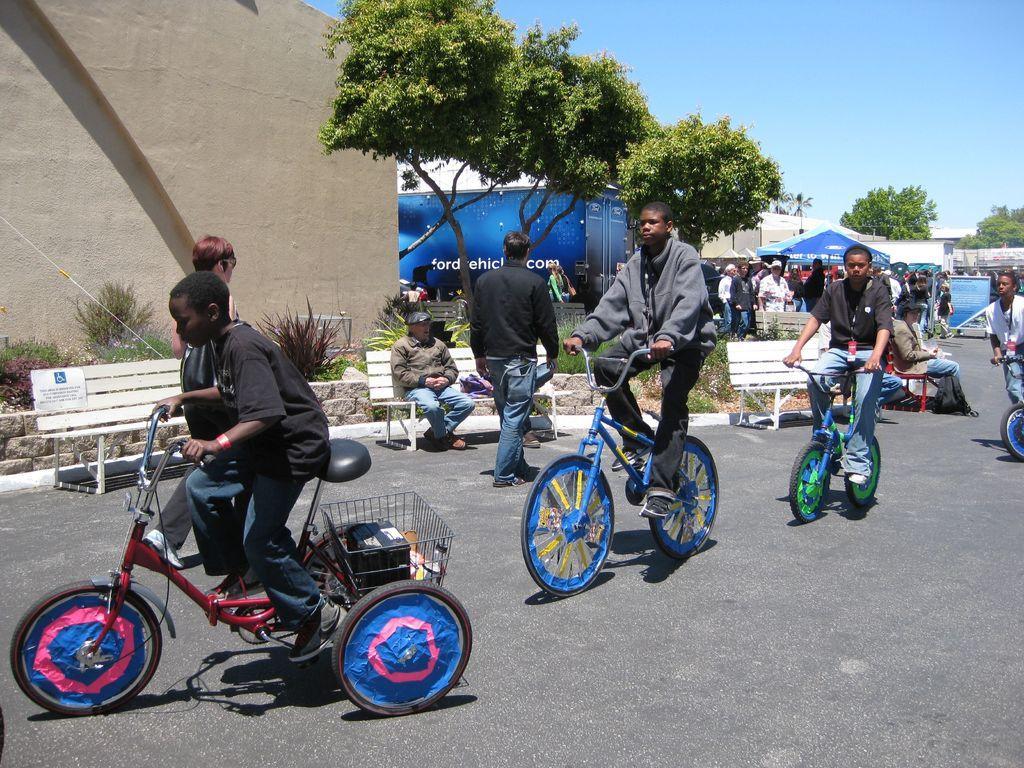How would you summarize this image in a sentence or two? There are few people riding bicycle on the road. Behind them there are few people,wall,building,trees,tents,hoarding and sky. 